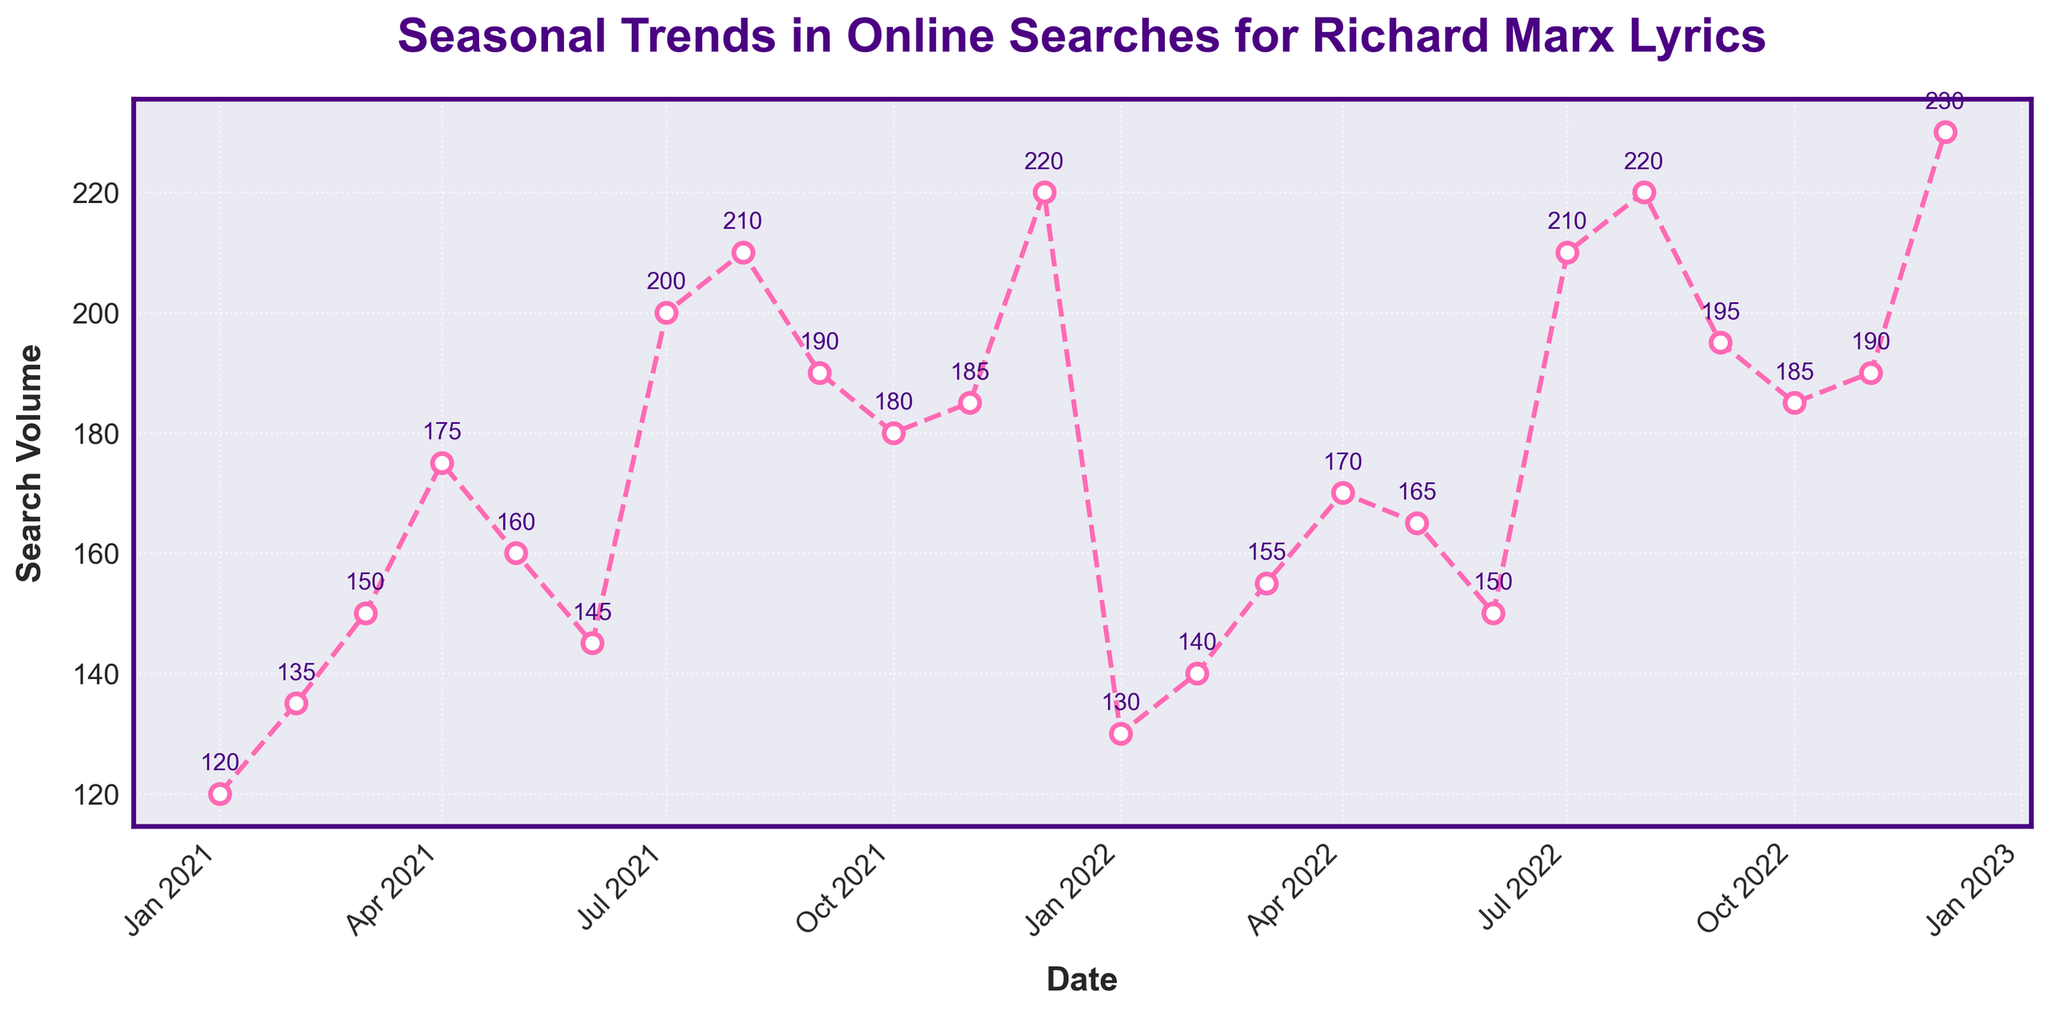What's the title of the figure? The title of the figure is placed at the top and it summarizes the content of the plot. It is "Seasonal Trends in Online Searches for Richard Marx Lyrics". Just read the title from the plot to get your answer.
Answer: Seasonal Trends in Online Searches for Richard Marx Lyrics Which month has the highest search volume in 2021? To determine the month with the highest search volume, check all the data points corresponding to 2021 and identify the highest value. December 2021 has the highest search volume of 220.
Answer: December 2021 How does the search volume in July 2022 compare to July 2021? Compare the data points for July 2022 and July 2021 by checking their search volumes. The search volume in July 2022 (210) is higher than in July 2021 (200).
Answer: Higher What trend do you observe in the search volume from January to December in 2022? To see the trend, follow the data points from January to December 2022. The search volume starts at 130 in January and ends at 230 in December, showing a gradual increase with some fluctuations.
Answer: Increasing Calculate the average search volume for 2021. Sum all the search volumes for 2021 and divide by the number of months (12). The total is 2105, so the average is 2105/12 = 175.42 (rounded to two decimal places).
Answer: 175.42 Was the search volume higher in August 2021 or August 2022? To determine this, look at the specific data points for August 2021 and August 2022. The search volume in August 2021 is 210, while in August 2022 it is 220. Therefore, August 2022 is higher.
Answer: August 2022 What is the difference in search volume between the highest and lowest points in 2022? Identify the highest and lowest points in 2022. The highest is 230 in December, and the lowest is 130 in January. Subtract the lowest from the highest to get the difference: 230 - 130 = 100.
Answer: 100 In which months do the search volumes show a significant drop in 2021? Check for any significant decreases month-to-month in 2021. One such drop is from May (160) to June (145).
Answer: June 2021 